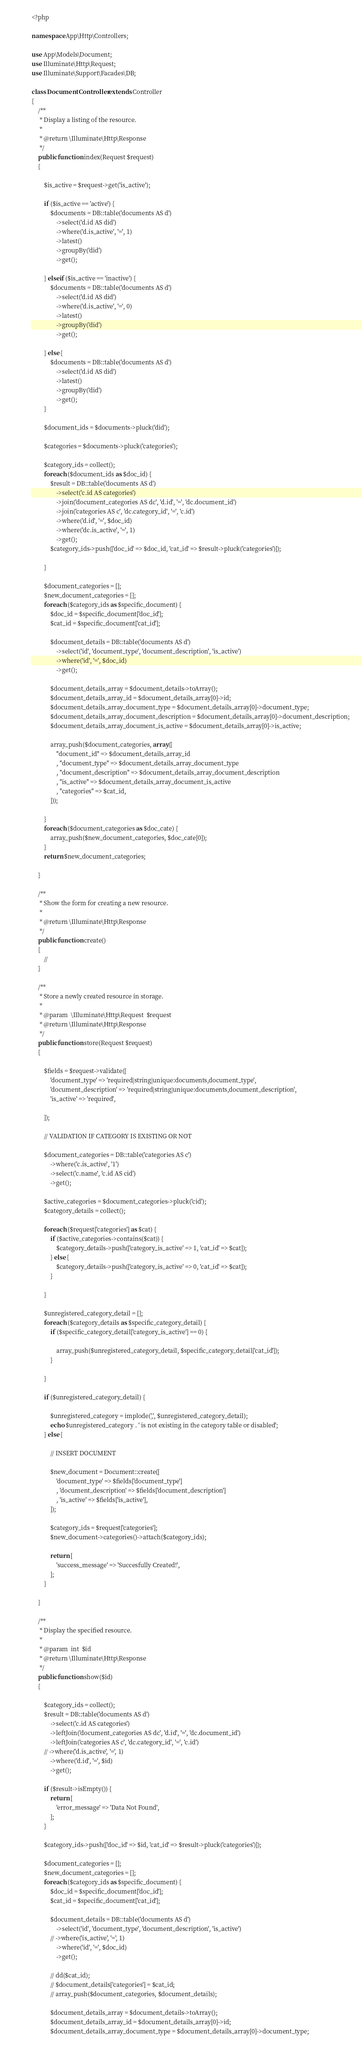<code> <loc_0><loc_0><loc_500><loc_500><_PHP_><?php

namespace App\Http\Controllers;

use App\Models\Document;
use Illuminate\Http\Request;
use Illuminate\Support\Facades\DB;

class DocumentController extends Controller
{
    /**
     * Display a listing of the resource.
     *
     * @return \Illuminate\Http\Response
     */
    public function index(Request $request)
    {

        $is_active = $request->get('is_active');

        if ($is_active == 'active') {
            $documents = DB::table('documents AS d')
                ->select('d.id AS did')
                ->where('d.is_active', '=', 1)
                ->latest()
                ->groupBy('did')
                ->get();

        } elseif ($is_active == 'inactive') {
            $documents = DB::table('documents AS d')
                ->select('d.id AS did')
                ->where('d.is_active', '=', 0)
                ->latest()
                ->groupBy('did')
                ->get();

        } else {
            $documents = DB::table('documents AS d')
                ->select('d.id AS did')
                ->latest()
                ->groupBy('did')
                ->get();
        }

        $document_ids = $documents->pluck('did');

        $categories = $documents->pluck('categories');

        $category_ids = collect();
        foreach ($document_ids as $doc_id) {
            $result = DB::table('documents AS d')
                ->select('c.id AS categories')
                ->join('document_categories AS dc', 'd.id', '=', 'dc.document_id')
                ->join('categories AS c', 'dc.category_id', '=', 'c.id')
                ->where('d.id', '=', $doc_id)
                ->where('dc.is_active', '=', 1)
                ->get();
            $category_ids->push(['doc_id' => $doc_id, 'cat_id' => $result->pluck('categories')]);

        }

        $document_categories = [];
        $new_document_categories = [];
        foreach ($category_ids as $specific_document) {
            $doc_id = $specific_document['doc_id'];
            $cat_id = $specific_document['cat_id'];

            $document_details = DB::table('documents AS d')
                ->select('id', 'document_type', 'document_description', 'is_active')
                ->where('id', '=', $doc_id)
                ->get();

            $document_details_array = $document_details->toArray();
            $document_details_array_id = $document_details_array[0]->id;
            $document_details_array_document_type = $document_details_array[0]->document_type;
            $document_details_array_document_description = $document_details_array[0]->document_description;
            $document_details_array_document_is_active = $document_details_array[0]->is_active;

            array_push($document_categories, array([
                "document_id" => $document_details_array_id
                , "document_type" => $document_details_array_document_type
                , "document_description" => $document_details_array_document_description
                , "is_active" => $document_details_array_document_is_active
                , "categories" => $cat_id,
            ]));

        }
        foreach ($document_categories as $doc_cate) {
            array_push($new_document_categories, $doc_cate[0]);
        }
        return $new_document_categories;

    }

    /**
     * Show the form for creating a new resource.
     *
     * @return \Illuminate\Http\Response
     */
    public function create()
    {
        //
    }

    /**
     * Store a newly created resource in storage.
     *
     * @param  \Illuminate\Http\Request  $request
     * @return \Illuminate\Http\Response
     */
    public function store(Request $request)
    {

        $fields = $request->validate([
            'document_type' => 'required|string|unique:documents,document_type',
            'document_description' => 'required|string|unique:documents,document_description',
            'is_active' => 'required',

        ]);

        // VALIDATION IF CATEGORY IS EXISTING OR NOT

        $document_categories = DB::table('categories AS c')
            ->where('c.is_active', '1')
            ->select('c.name', 'c.id AS cid')
            ->get();

        $active_categories = $document_categories->pluck('cid');
        $category_details = collect();

        foreach ($request['categories'] as $cat) {
            if ($active_categories->contains($cat)) {
                $category_details->push(['category_is_active' => 1, 'cat_id' => $cat]);
            } else {
                $category_details->push(['category_is_active' => 0, 'cat_id' => $cat]);
            }

        }

        $unregistered_category_detail = [];
        foreach ($category_details as $specific_category_detail) {
            if ($specific_category_detail['category_is_active'] == 0) {

                array_push($unregistered_category_detail, $specific_category_detail['cat_id']);
            }

        }

        if ($unregistered_category_detail) {

            $unregistered_category = implode(',', $unregistered_category_detail);
            echo $unregistered_category . ' is not existing in the category table or disabled';
        } else {

            // INSERT DOCUMENT

            $new_document = Document::create([
                'document_type' => $fields['document_type']
                , 'document_description' => $fields['document_description']
                , 'is_active' => $fields['is_active'],
            ]);

            $category_ids = $request['categories'];
            $new_document->categories()->attach($category_ids);

            return [
                'success_message' => 'Succesfully Created!',
            ];
        }

    }

    /**
     * Display the specified resource.
     *
     * @param  int  $id
     * @return \Illuminate\Http\Response
     */
    public function show($id)
    {

        $category_ids = collect();
        $result = DB::table('documents AS d')
            ->select('c.id AS categories')
            ->leftJoin('document_categories AS dc', 'd.id', '=', 'dc.document_id')
            ->leftJoin('categories AS c', 'dc.category_id', '=', 'c.id')
        // ->where('d.is_active', '=', 1)
            ->where('d.id', '=', $id)
            ->get();

        if ($result->isEmpty()) {
            return [
                'error_message' => 'Data Not Found',
            ];
        }

        $category_ids->push(['doc_id' => $id, 'cat_id' => $result->pluck('categories')]);

        $document_categories = [];
        $new_document_categories = [];
        foreach ($category_ids as $specific_document) {
            $doc_id = $specific_document['doc_id'];
            $cat_id = $specific_document['cat_id'];

            $document_details = DB::table('documents AS d')
                ->select('id', 'document_type', 'document_description', 'is_active')
            // ->where('is_active', '=', 1)
                ->where('id', '=', $doc_id)
                ->get();

            // dd($cat_id);
            // $document_details['categories'] = $cat_id;
            // array_push($document_categories, $document_details);

            $document_details_array = $document_details->toArray();
            $document_details_array_id = $document_details_array[0]->id;
            $document_details_array_document_type = $document_details_array[0]->document_type;</code> 